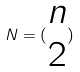<formula> <loc_0><loc_0><loc_500><loc_500>N = ( \begin{matrix} n \\ 2 \end{matrix} )</formula> 